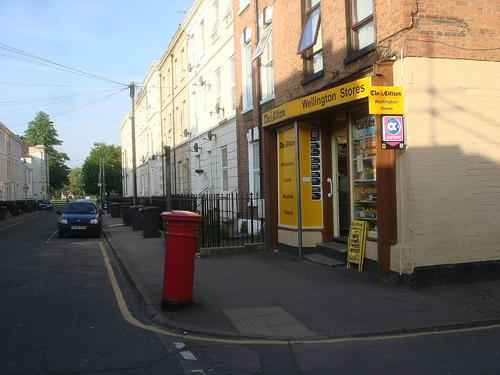<image>
Is the power lines above the car? Yes. The power lines is positioned above the car in the vertical space, higher up in the scene. 